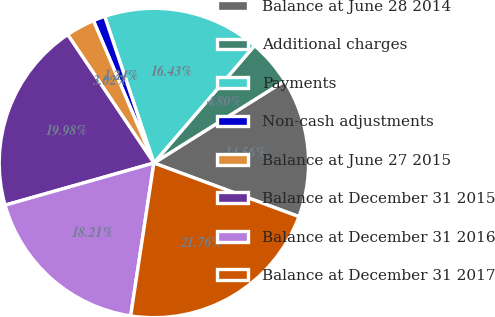Convert chart. <chart><loc_0><loc_0><loc_500><loc_500><pie_chart><fcel>Balance at June 28 2014<fcel>Additional charges<fcel>Payments<fcel>Non-cash adjustments<fcel>Balance at June 27 2015<fcel>Balance at December 31 2015<fcel>Balance at December 31 2016<fcel>Balance at December 31 2017<nl><fcel>14.56%<fcel>4.8%<fcel>16.43%<fcel>1.24%<fcel>3.02%<fcel>19.98%<fcel>18.21%<fcel>21.76%<nl></chart> 